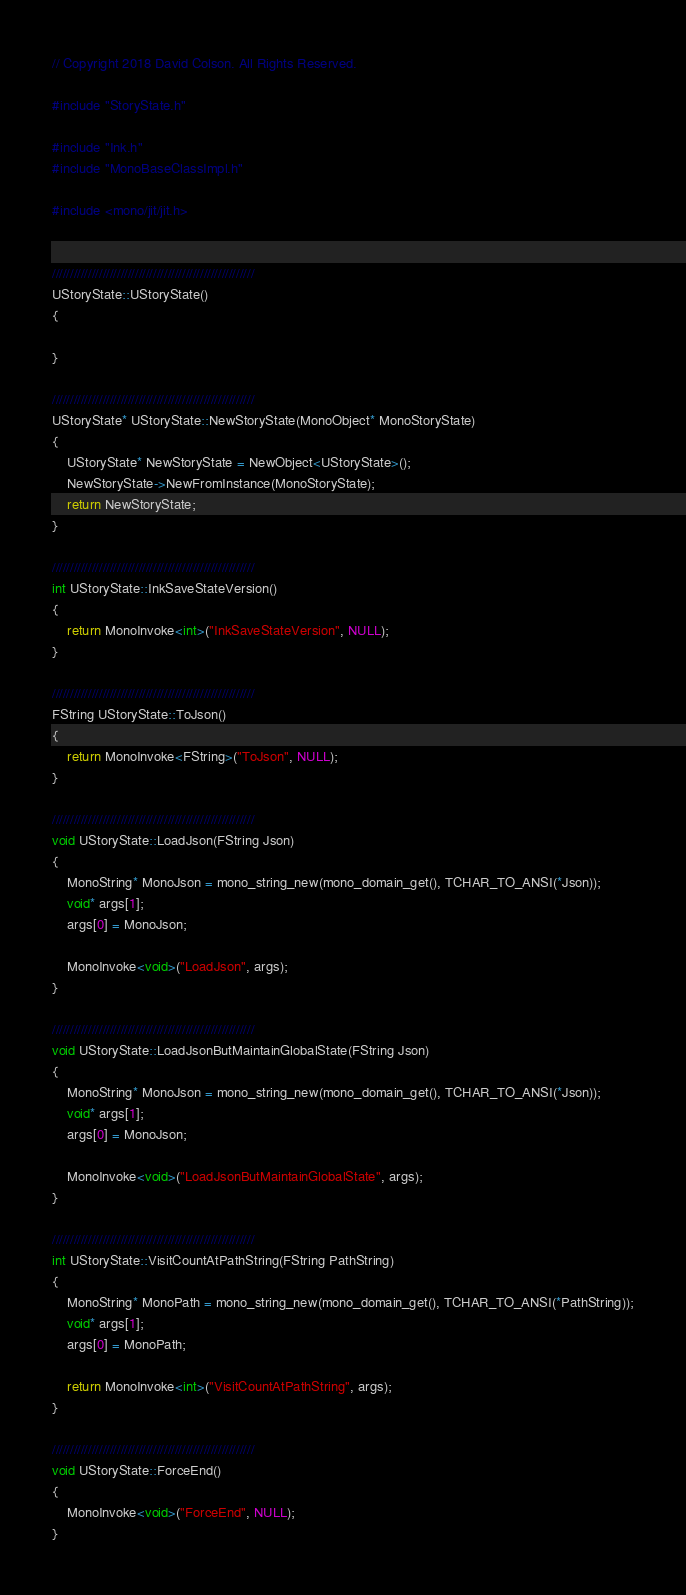<code> <loc_0><loc_0><loc_500><loc_500><_C++_>// Copyright 2018 David Colson. All Rights Reserved.

#include "StoryState.h"

#include "Ink.h"
#include "MonoBaseClassImpl.h"

#include <mono/jit/jit.h>


////////////////////////////////////////////////////////
UStoryState::UStoryState()
{

}

////////////////////////////////////////////////////////
UStoryState* UStoryState::NewStoryState(MonoObject* MonoStoryState)
{
	UStoryState* NewStoryState = NewObject<UStoryState>();
	NewStoryState->NewFromInstance(MonoStoryState);
	return NewStoryState;
}

////////////////////////////////////////////////////////
int UStoryState::InkSaveStateVersion()
{
	return MonoInvoke<int>("InkSaveStateVersion", NULL);
}

////////////////////////////////////////////////////////
FString UStoryState::ToJson()
{
	return MonoInvoke<FString>("ToJson", NULL);
}

////////////////////////////////////////////////////////
void UStoryState::LoadJson(FString Json)
{
	MonoString* MonoJson = mono_string_new(mono_domain_get(), TCHAR_TO_ANSI(*Json));
	void* args[1];
	args[0] = MonoJson;

	MonoInvoke<void>("LoadJson", args);
}

////////////////////////////////////////////////////////
void UStoryState::LoadJsonButMaintainGlobalState(FString Json)
{
	MonoString* MonoJson = mono_string_new(mono_domain_get(), TCHAR_TO_ANSI(*Json));
	void* args[1];
	args[0] = MonoJson;

	MonoInvoke<void>("LoadJsonButMaintainGlobalState", args);
}

////////////////////////////////////////////////////////
int UStoryState::VisitCountAtPathString(FString PathString)
{
	MonoString* MonoPath = mono_string_new(mono_domain_get(), TCHAR_TO_ANSI(*PathString));
	void* args[1];
	args[0] = MonoPath;

	return MonoInvoke<int>("VisitCountAtPathString", args);
}

////////////////////////////////////////////////////////
void UStoryState::ForceEnd()
{
	MonoInvoke<void>("ForceEnd", NULL);
}
</code> 